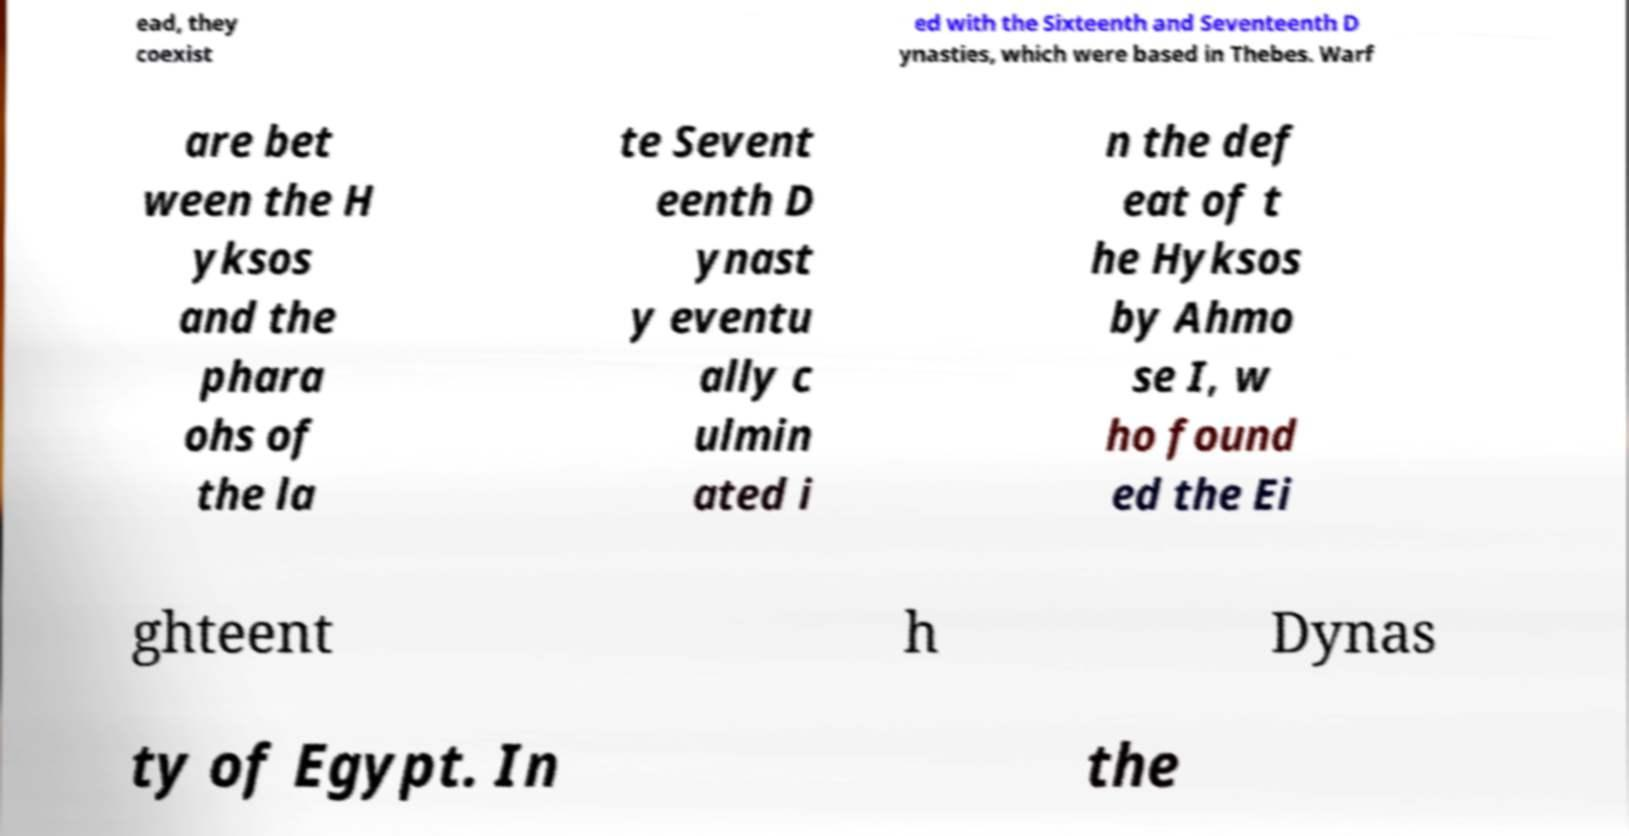Could you extract and type out the text from this image? ead, they coexist ed with the Sixteenth and Seventeenth D ynasties, which were based in Thebes. Warf are bet ween the H yksos and the phara ohs of the la te Sevent eenth D ynast y eventu ally c ulmin ated i n the def eat of t he Hyksos by Ahmo se I, w ho found ed the Ei ghteent h Dynas ty of Egypt. In the 